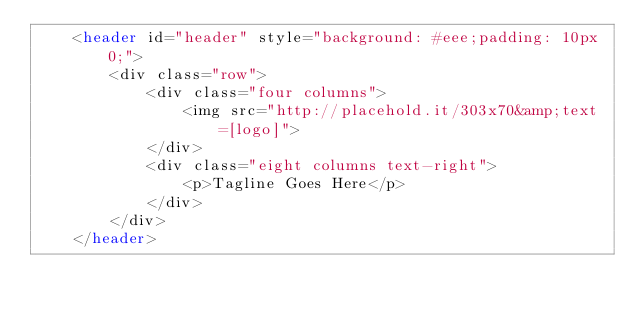Convert code to text. <code><loc_0><loc_0><loc_500><loc_500><_PHP_>    <header id="header" style="background: #eee;padding: 10px 0;">
    	<div class="row">
	        <div class="four columns">
	            <img src="http://placehold.it/303x70&amp;text=[logo]">
	        </div>
	        <div class="eight columns text-right">
	        	<p>Tagline Goes Here</p>
	        </div>
	    </div>
    </header></code> 